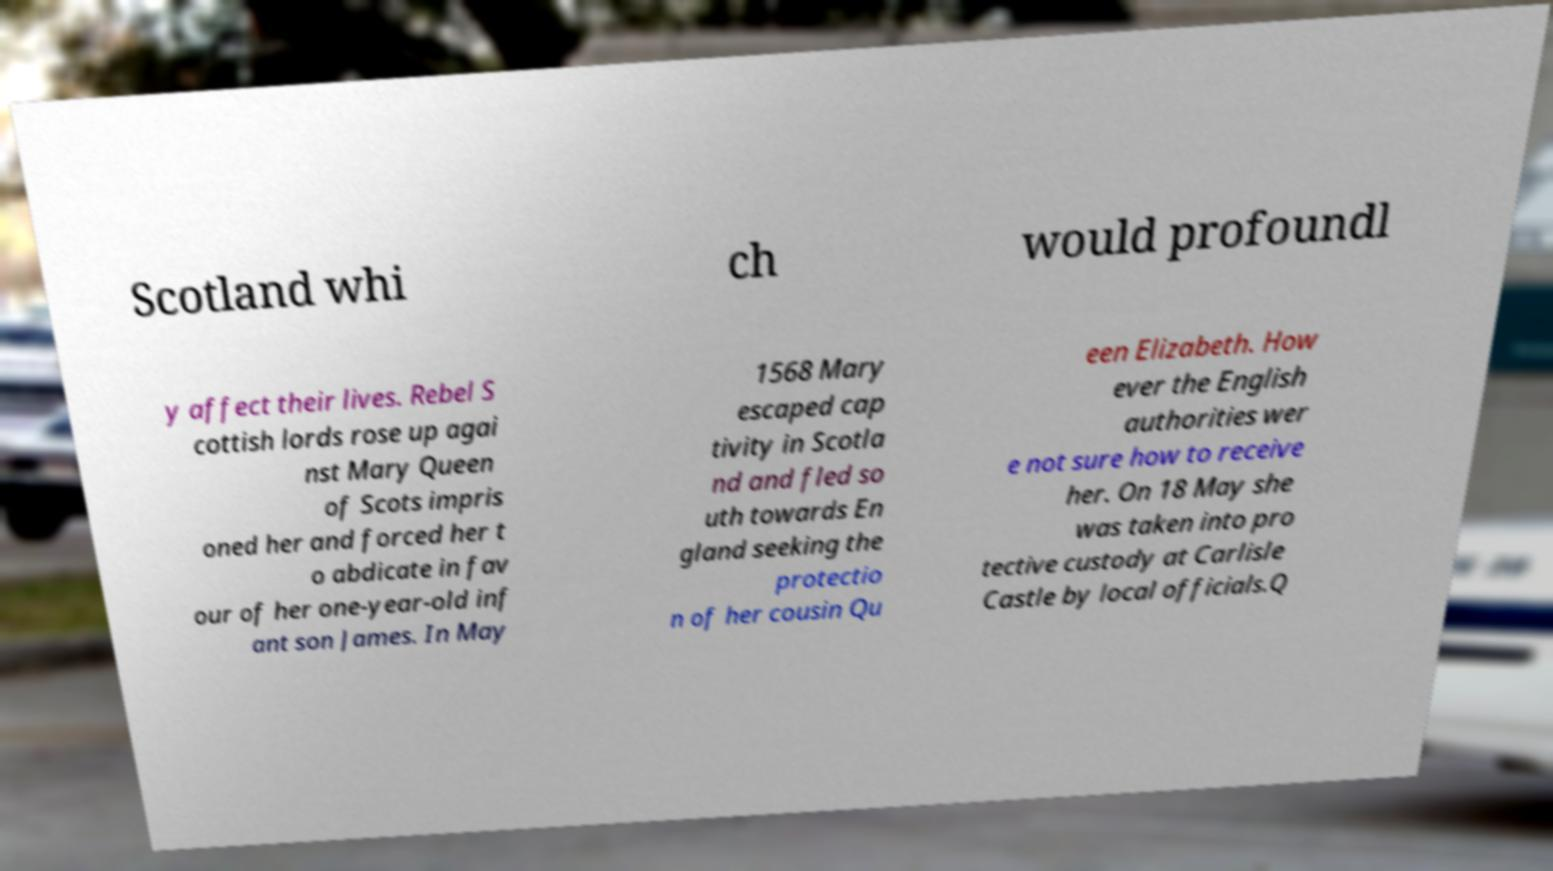Please read and relay the text visible in this image. What does it say? Scotland whi ch would profoundl y affect their lives. Rebel S cottish lords rose up agai nst Mary Queen of Scots impris oned her and forced her t o abdicate in fav our of her one-year-old inf ant son James. In May 1568 Mary escaped cap tivity in Scotla nd and fled so uth towards En gland seeking the protectio n of her cousin Qu een Elizabeth. How ever the English authorities wer e not sure how to receive her. On 18 May she was taken into pro tective custody at Carlisle Castle by local officials.Q 